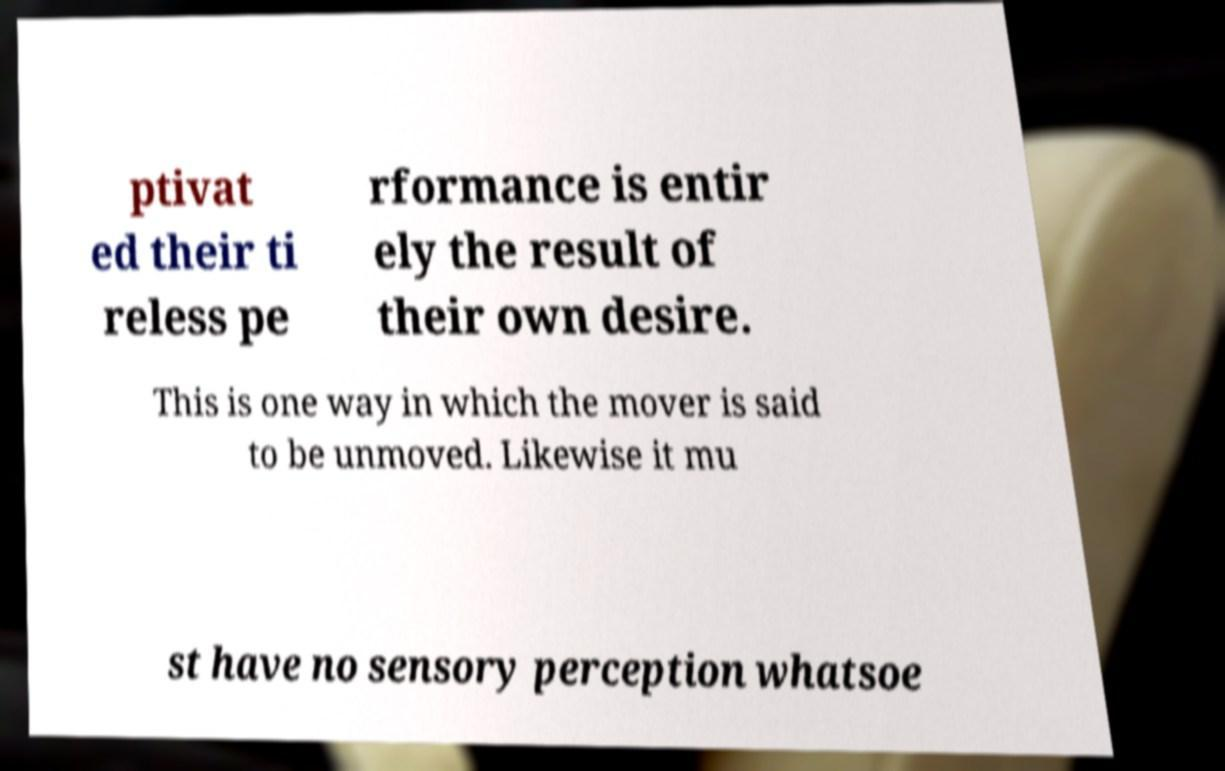For documentation purposes, I need the text within this image transcribed. Could you provide that? ptivat ed their ti reless pe rformance is entir ely the result of their own desire. This is one way in which the mover is said to be unmoved. Likewise it mu st have no sensory perception whatsoe 